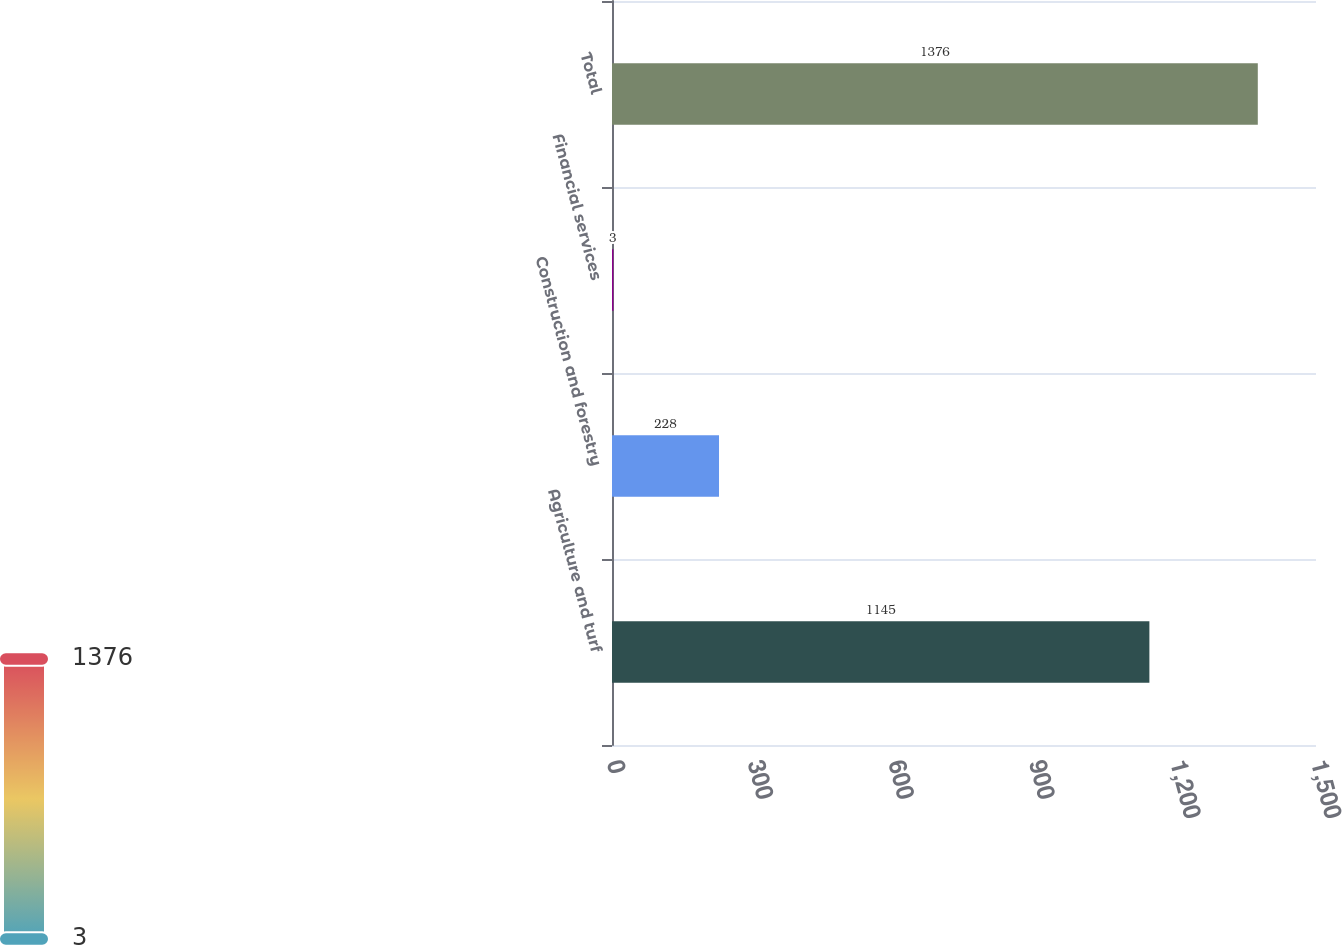Convert chart. <chart><loc_0><loc_0><loc_500><loc_500><bar_chart><fcel>Agriculture and turf<fcel>Construction and forestry<fcel>Financial services<fcel>Total<nl><fcel>1145<fcel>228<fcel>3<fcel>1376<nl></chart> 